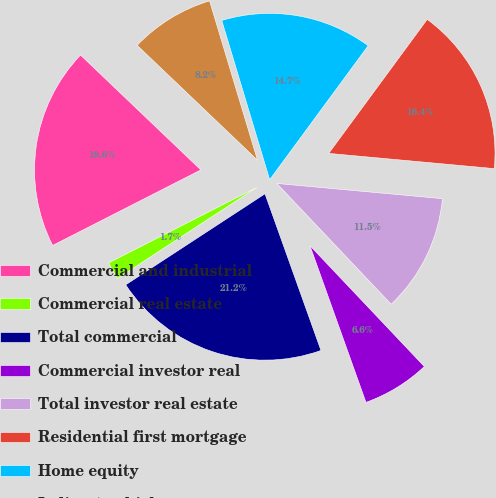Convert chart. <chart><loc_0><loc_0><loc_500><loc_500><pie_chart><fcel>Commercial and industrial<fcel>Commercial real estate<fcel>Total commercial<fcel>Commercial investor real<fcel>Total investor real estate<fcel>Residential first mortgage<fcel>Home equity<fcel>Indirect-vehicles<nl><fcel>19.63%<fcel>1.71%<fcel>21.25%<fcel>6.6%<fcel>11.48%<fcel>16.37%<fcel>14.74%<fcel>8.22%<nl></chart> 